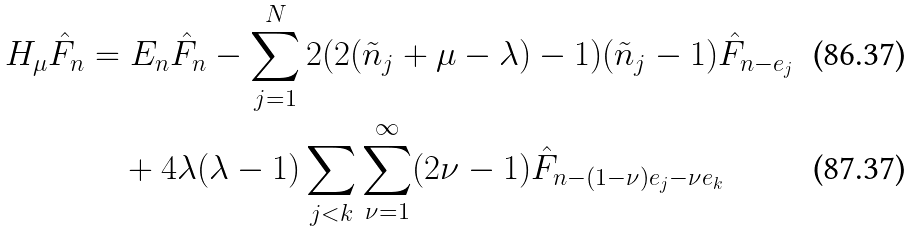Convert formula to latex. <formula><loc_0><loc_0><loc_500><loc_500>H _ { \mu } \hat { F } _ { n } & = E _ { n } \hat { F } _ { n } - \sum _ { j = 1 } ^ { N } 2 ( 2 ( \tilde { n } _ { j } + \mu - \lambda ) - 1 ) ( \tilde { n } _ { j } - 1 ) \hat { F } _ { n - e _ { j } } \\ & \quad + 4 \lambda ( \lambda - 1 ) \sum _ { j < k } \sum _ { \nu = 1 } ^ { \infty } ( 2 \nu - 1 ) \hat { F } _ { n - ( 1 - \nu ) e _ { j } - \nu e _ { k } }</formula> 